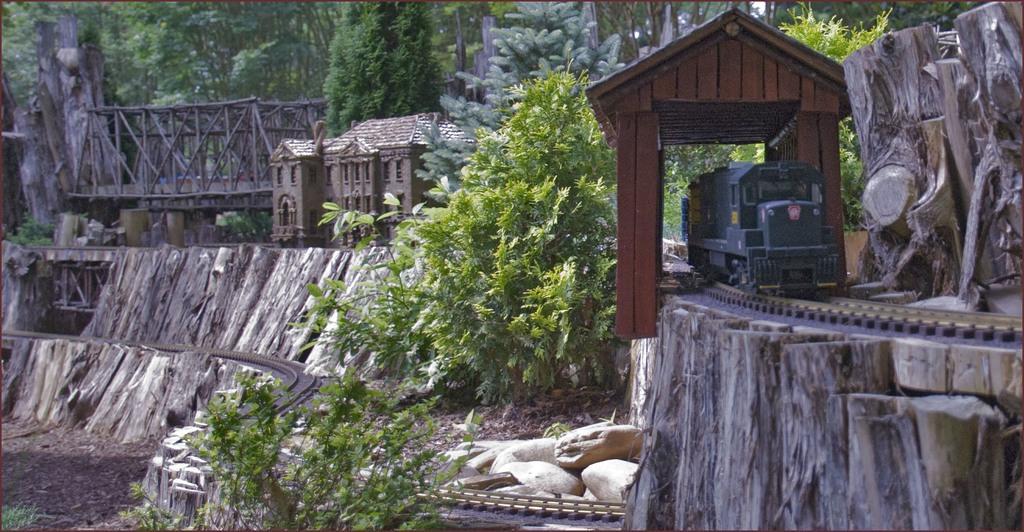How would you summarize this image in a sentence or two? In this image we can see a house, bridge, train, railway track, plants, bark, stones and trees. 